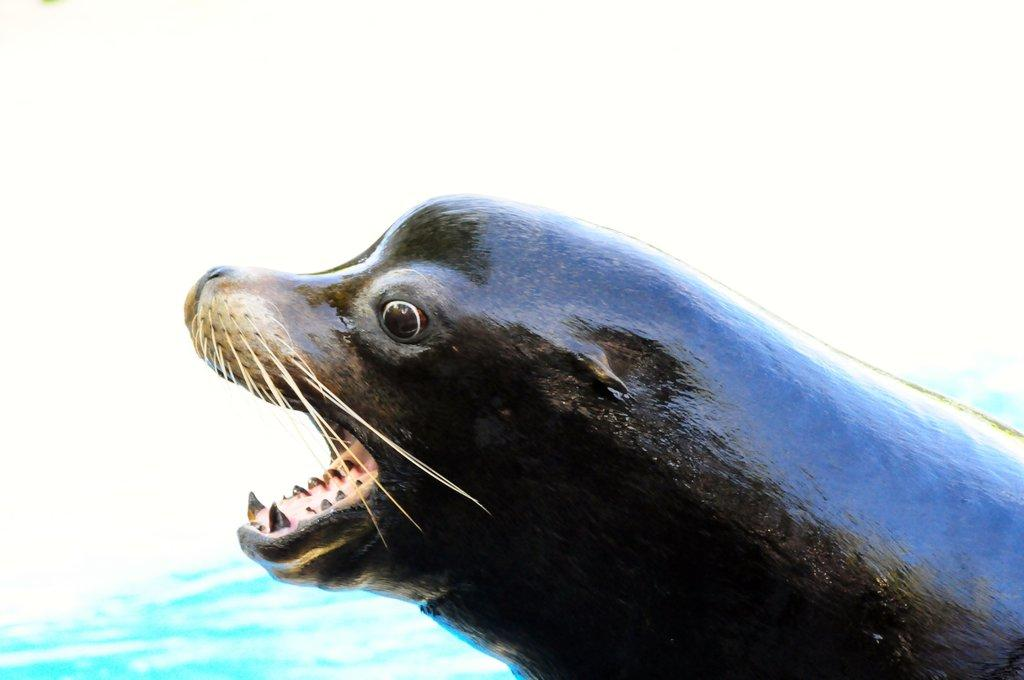What is present at the bottom of the image? There is water at the bottom of the image. What animal can be seen in the middle of the image? There is a seal in the middle of the image. What type of machine is visible in the image? A: There is no machine present in the image; it features water and a seal. What experience can be observed in the image? There is no experience depicted in the image; it simply shows water and a seal. 